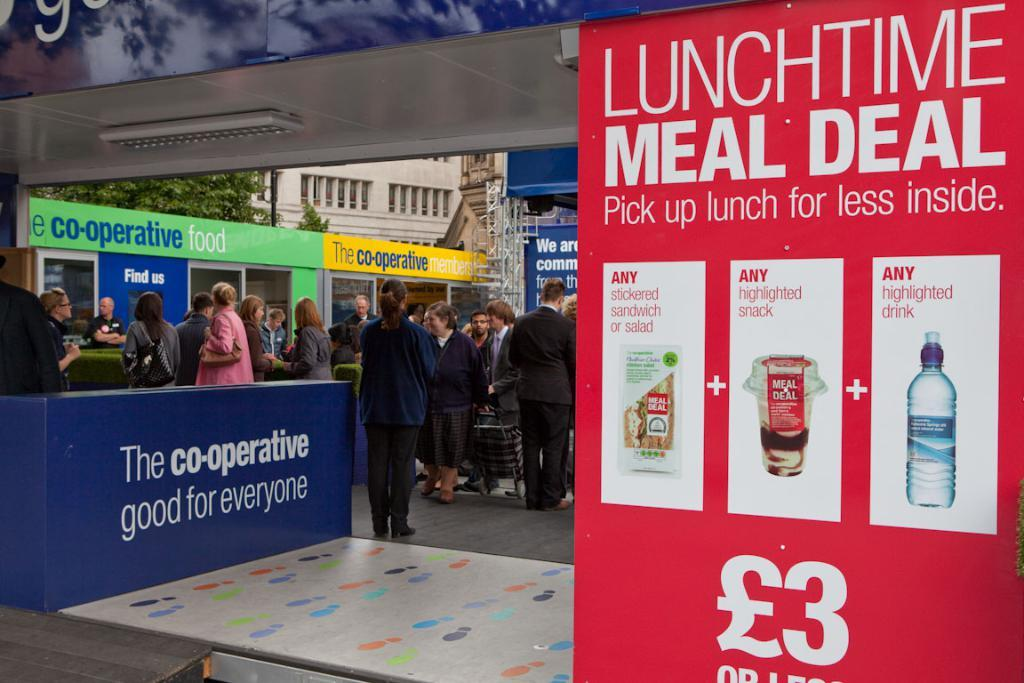What is the color of the banner in the image? The banner in the image is red. Who can be seen in the image? There are men and women standing in the image. What can be seen in the background of the image? There is a building and a tree in the background of the image. What type of oatmeal is being served at the event in the image? There is no mention of oatmeal or any event in the image; it simply shows a red banner with people standing nearby and a background with a building and a tree. 